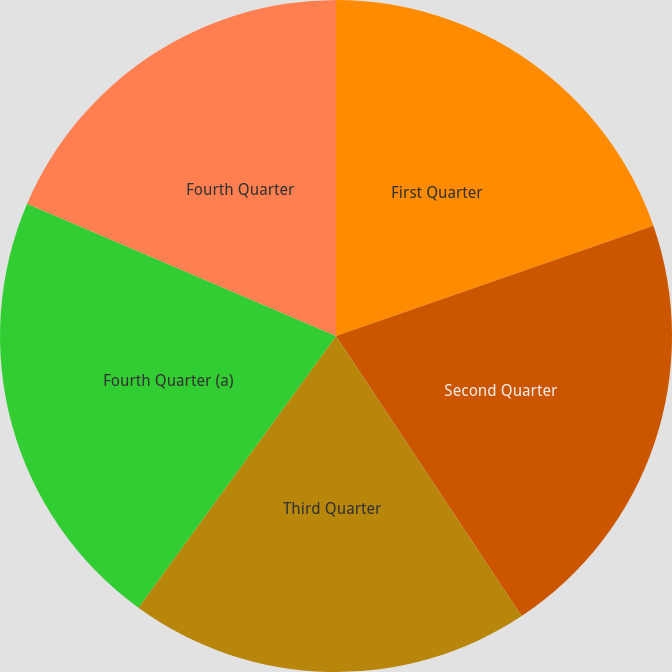<chart> <loc_0><loc_0><loc_500><loc_500><pie_chart><fcel>First Quarter<fcel>Second Quarter<fcel>Third Quarter<fcel>Fourth Quarter (a)<fcel>Fourth Quarter<nl><fcel>19.68%<fcel>21.0%<fcel>19.32%<fcel>21.43%<fcel>18.56%<nl></chart> 